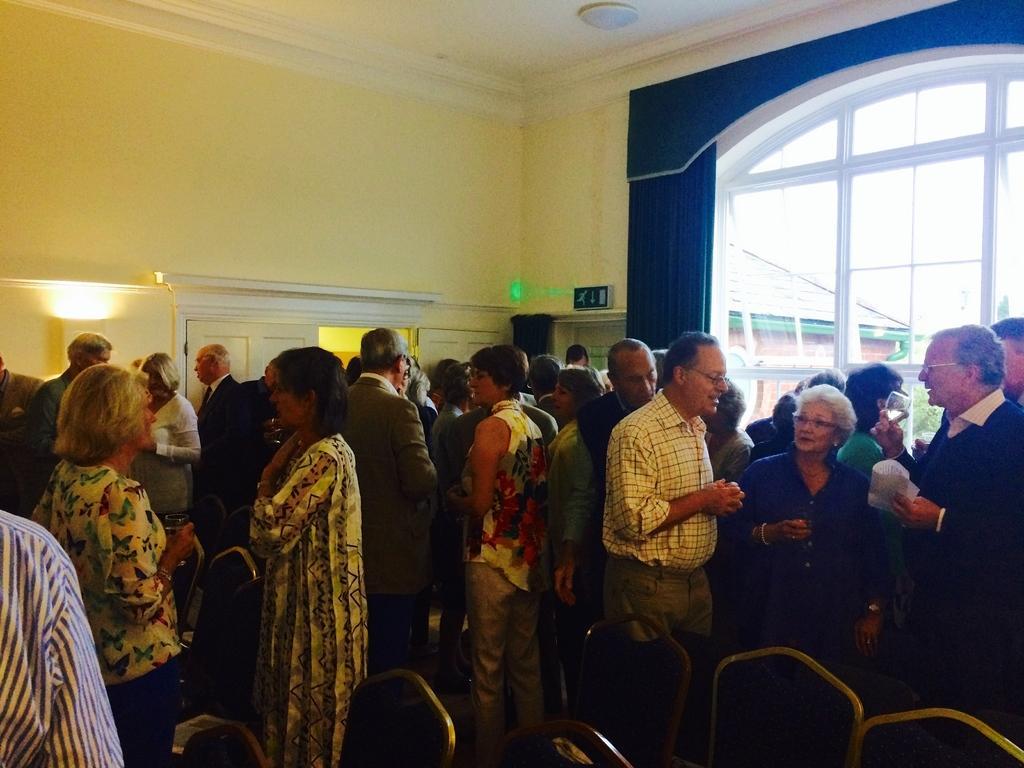In one or two sentences, can you explain what this image depicts? In this image, there are a few people. We can see some chairs. We can see the wall with some doors. We can see a signboard. We can also see some glass and the curtain. We can also see a house. We can see the roof with an object. 